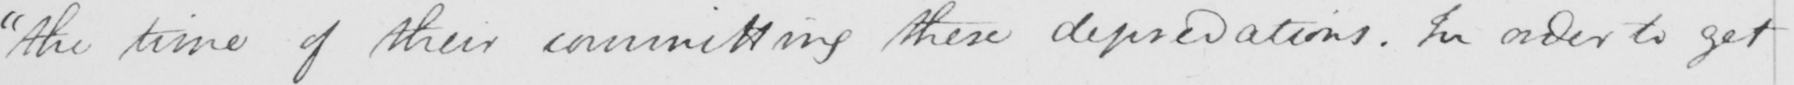What does this handwritten line say? "the time of their committing these depravations. In order to get 